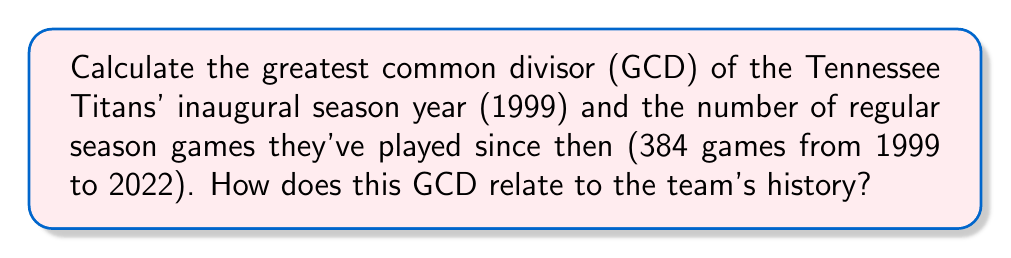Can you answer this question? Let's approach this step-by-step using the Euclidean algorithm:

1) We start with 1999 and 384.

2) Divide 1999 by 384:
   $$1999 = 5 \times 384 + 79$$

3) Now divide 384 by 79:
   $$384 = 4 \times 79 + 68$$

4) Divide 79 by 68:
   $$79 = 1 \times 68 + 11$$

5) Divide 68 by 11:
   $$68 = 6 \times 11 + 2$$

6) Finally, divide 11 by 2:
   $$11 = 5 \times 2 + 1$$

7) The process stops here as the remainder is 1.

Therefore, the GCD of 1999 and 384 is 1.

This result shows that 1999 and 384 are coprime, meaning they have no common factors other than 1. In the context of the Titans' history, this could be interpreted as the uniqueness of their inaugural year (1999) in relation to their cumulative regular season games (384). It underscores the distinctive nature of the team's beginning and its subsequent journey, reinforcing the idea that each game since 1999 has contributed to building the team's legacy in a way that can't be evenly divided or grouped.
Answer: 1 